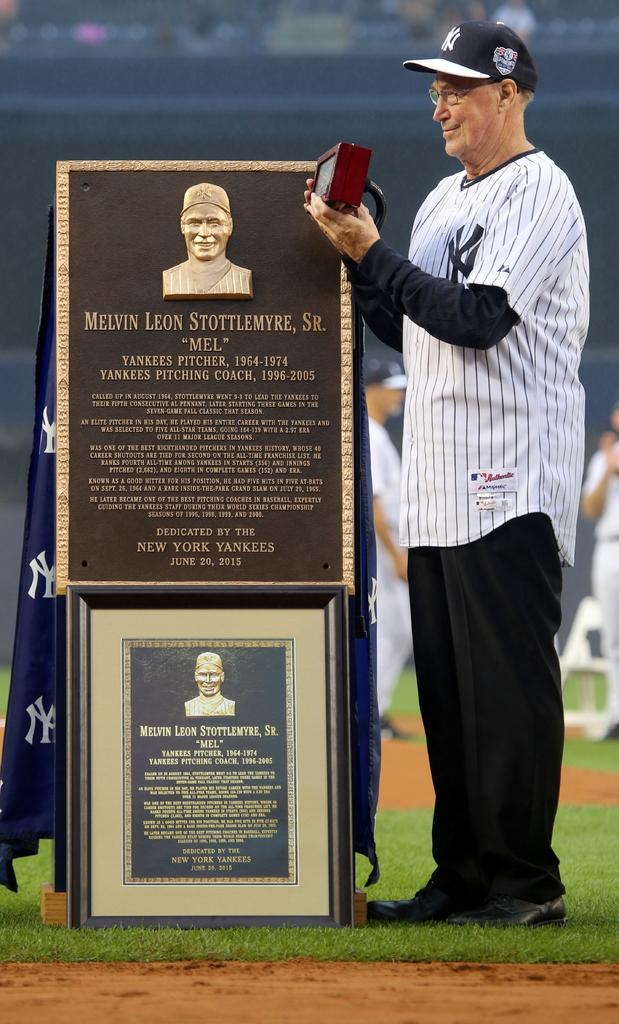Provide a one-sentence caption for the provided image. A retired baseball player from the Yankees from 1954-1974 is receiving  an award. 